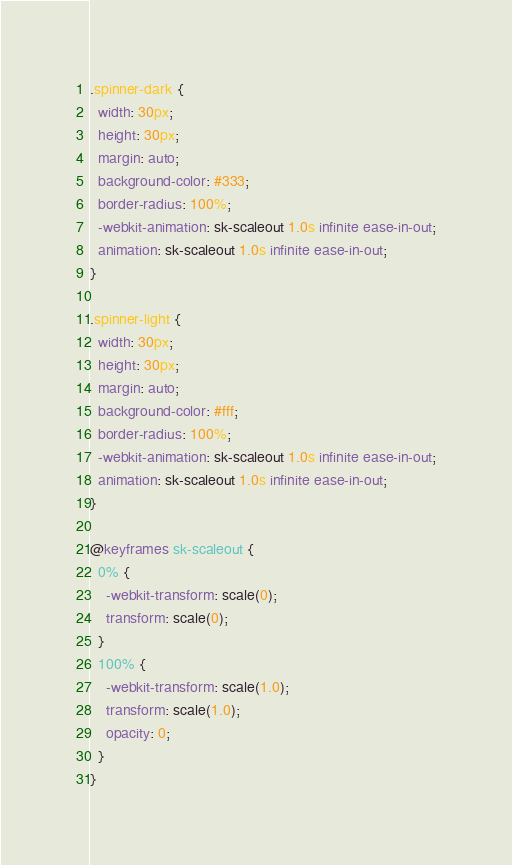<code> <loc_0><loc_0><loc_500><loc_500><_CSS_>.spinner-dark {
  width: 30px;
  height: 30px;
  margin: auto;
  background-color: #333;
  border-radius: 100%;
  -webkit-animation: sk-scaleout 1.0s infinite ease-in-out;
  animation: sk-scaleout 1.0s infinite ease-in-out;
}

.spinner-light {
  width: 30px;
  height: 30px;
  margin: auto;
  background-color: #fff;
  border-radius: 100%;
  -webkit-animation: sk-scaleout 1.0s infinite ease-in-out;
  animation: sk-scaleout 1.0s infinite ease-in-out;
}

@keyframes sk-scaleout {
  0% {
    -webkit-transform: scale(0);
    transform: scale(0);
  }
  100% {
    -webkit-transform: scale(1.0);
    transform: scale(1.0);
    opacity: 0;
  }
}

</code> 